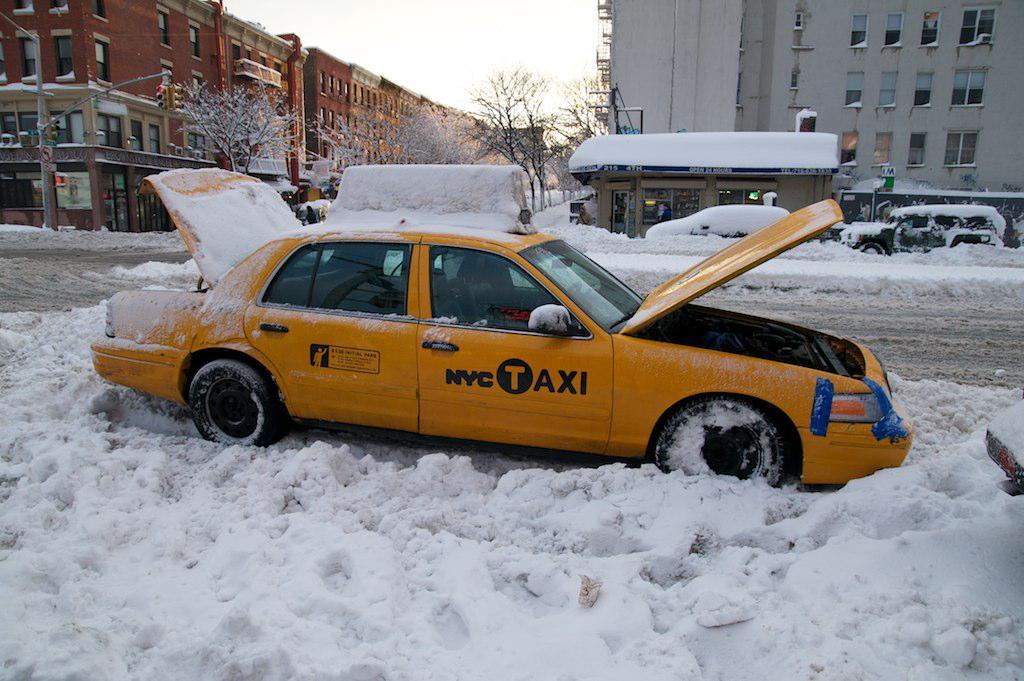What city does this taxi belong?
Your answer should be very brief. Nyc. 